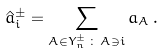<formula> <loc_0><loc_0><loc_500><loc_500>\hat { a } ^ { \pm } _ { i } = \sum _ { A \in Y ^ { \pm } _ { n } \, \colon \, A \ni i } a _ { A } \, .</formula> 